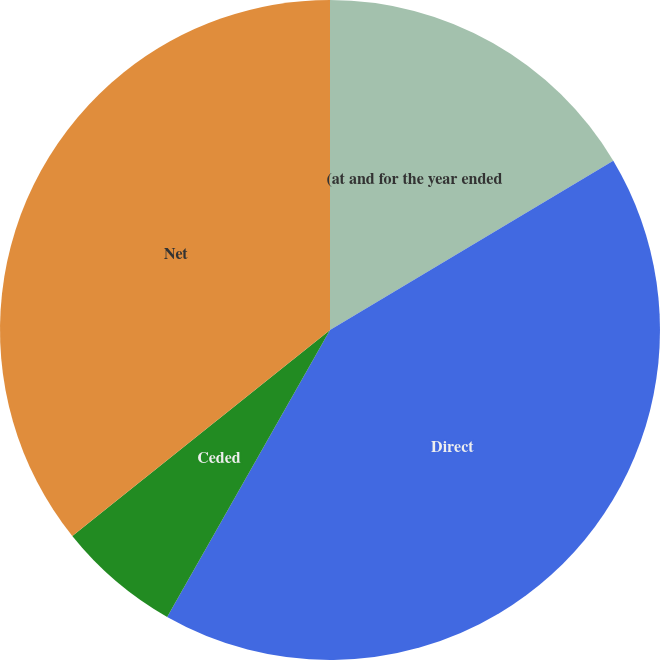Convert chart. <chart><loc_0><loc_0><loc_500><loc_500><pie_chart><fcel>(at and for the year ended<fcel>Direct<fcel>Ceded<fcel>Net<nl><fcel>16.43%<fcel>41.79%<fcel>6.05%<fcel>35.74%<nl></chart> 